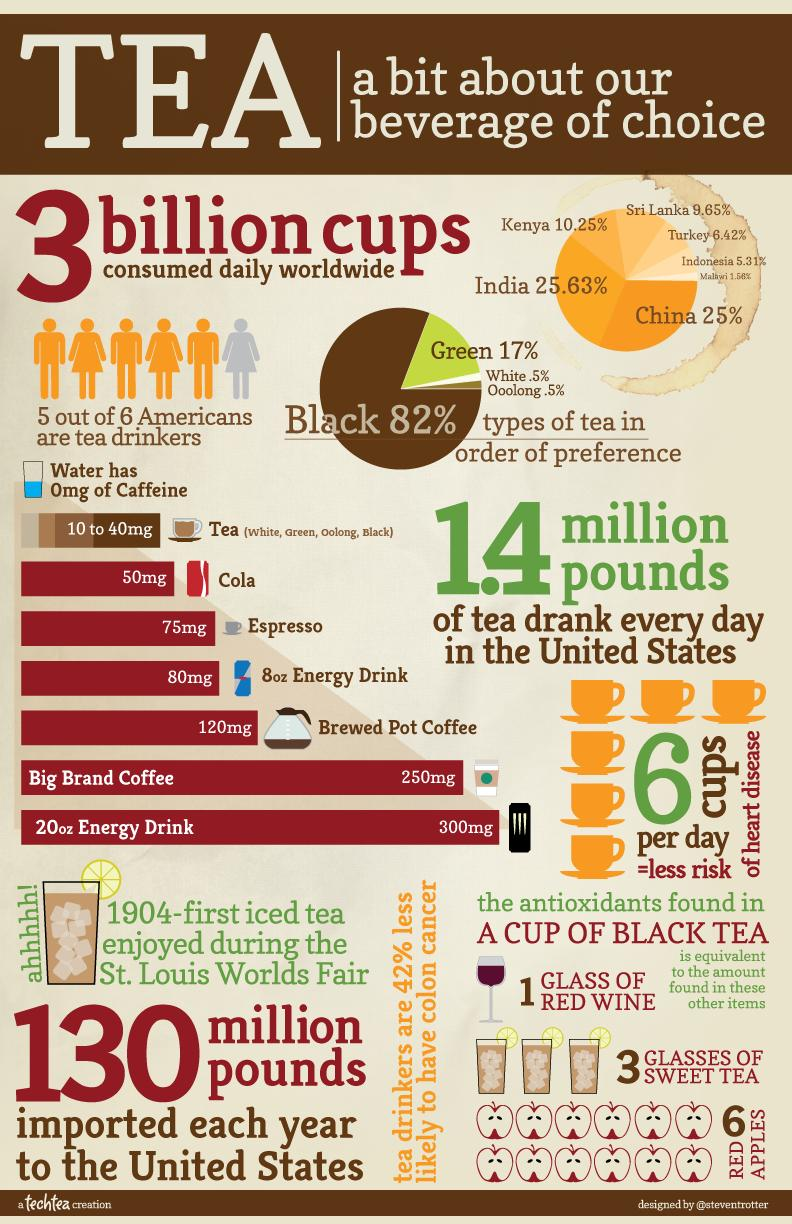Specify some key components in this picture. Approximately 0.5% of Americans consume white tea. A 50mg amount of caffeine is present in Cola. In India, approximately 25.63% of the population drink tea. According to a recent survey, 17% of Americans consume green tea on a regular basis. Big Brand Coffee contains 250mg of caffeine. 